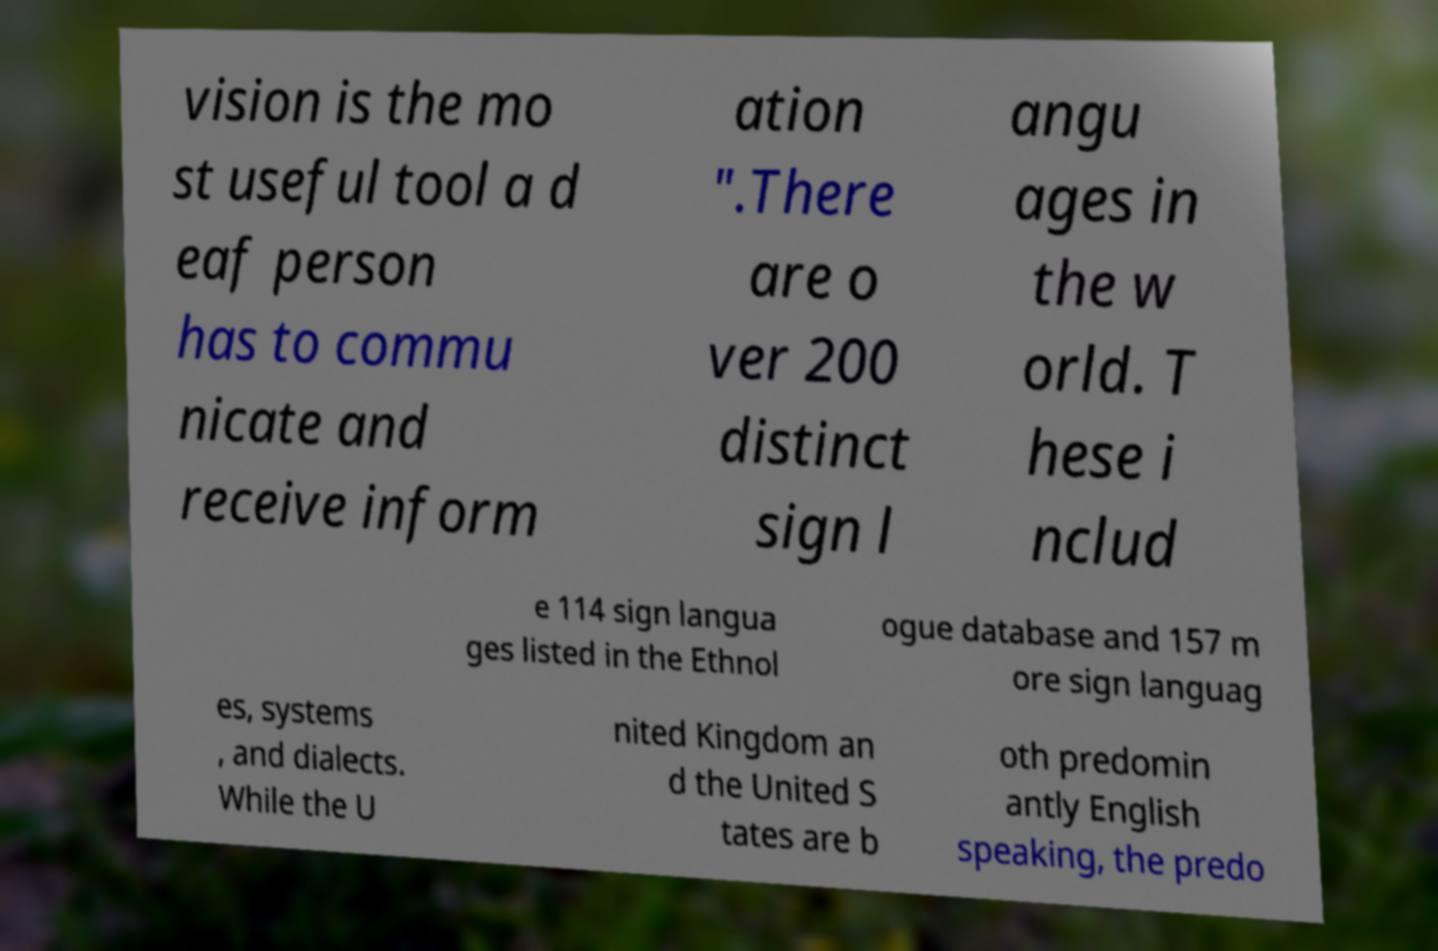There's text embedded in this image that I need extracted. Can you transcribe it verbatim? vision is the mo st useful tool a d eaf person has to commu nicate and receive inform ation ".There are o ver 200 distinct sign l angu ages in the w orld. T hese i nclud e 114 sign langua ges listed in the Ethnol ogue database and 157 m ore sign languag es, systems , and dialects. While the U nited Kingdom an d the United S tates are b oth predomin antly English speaking, the predo 